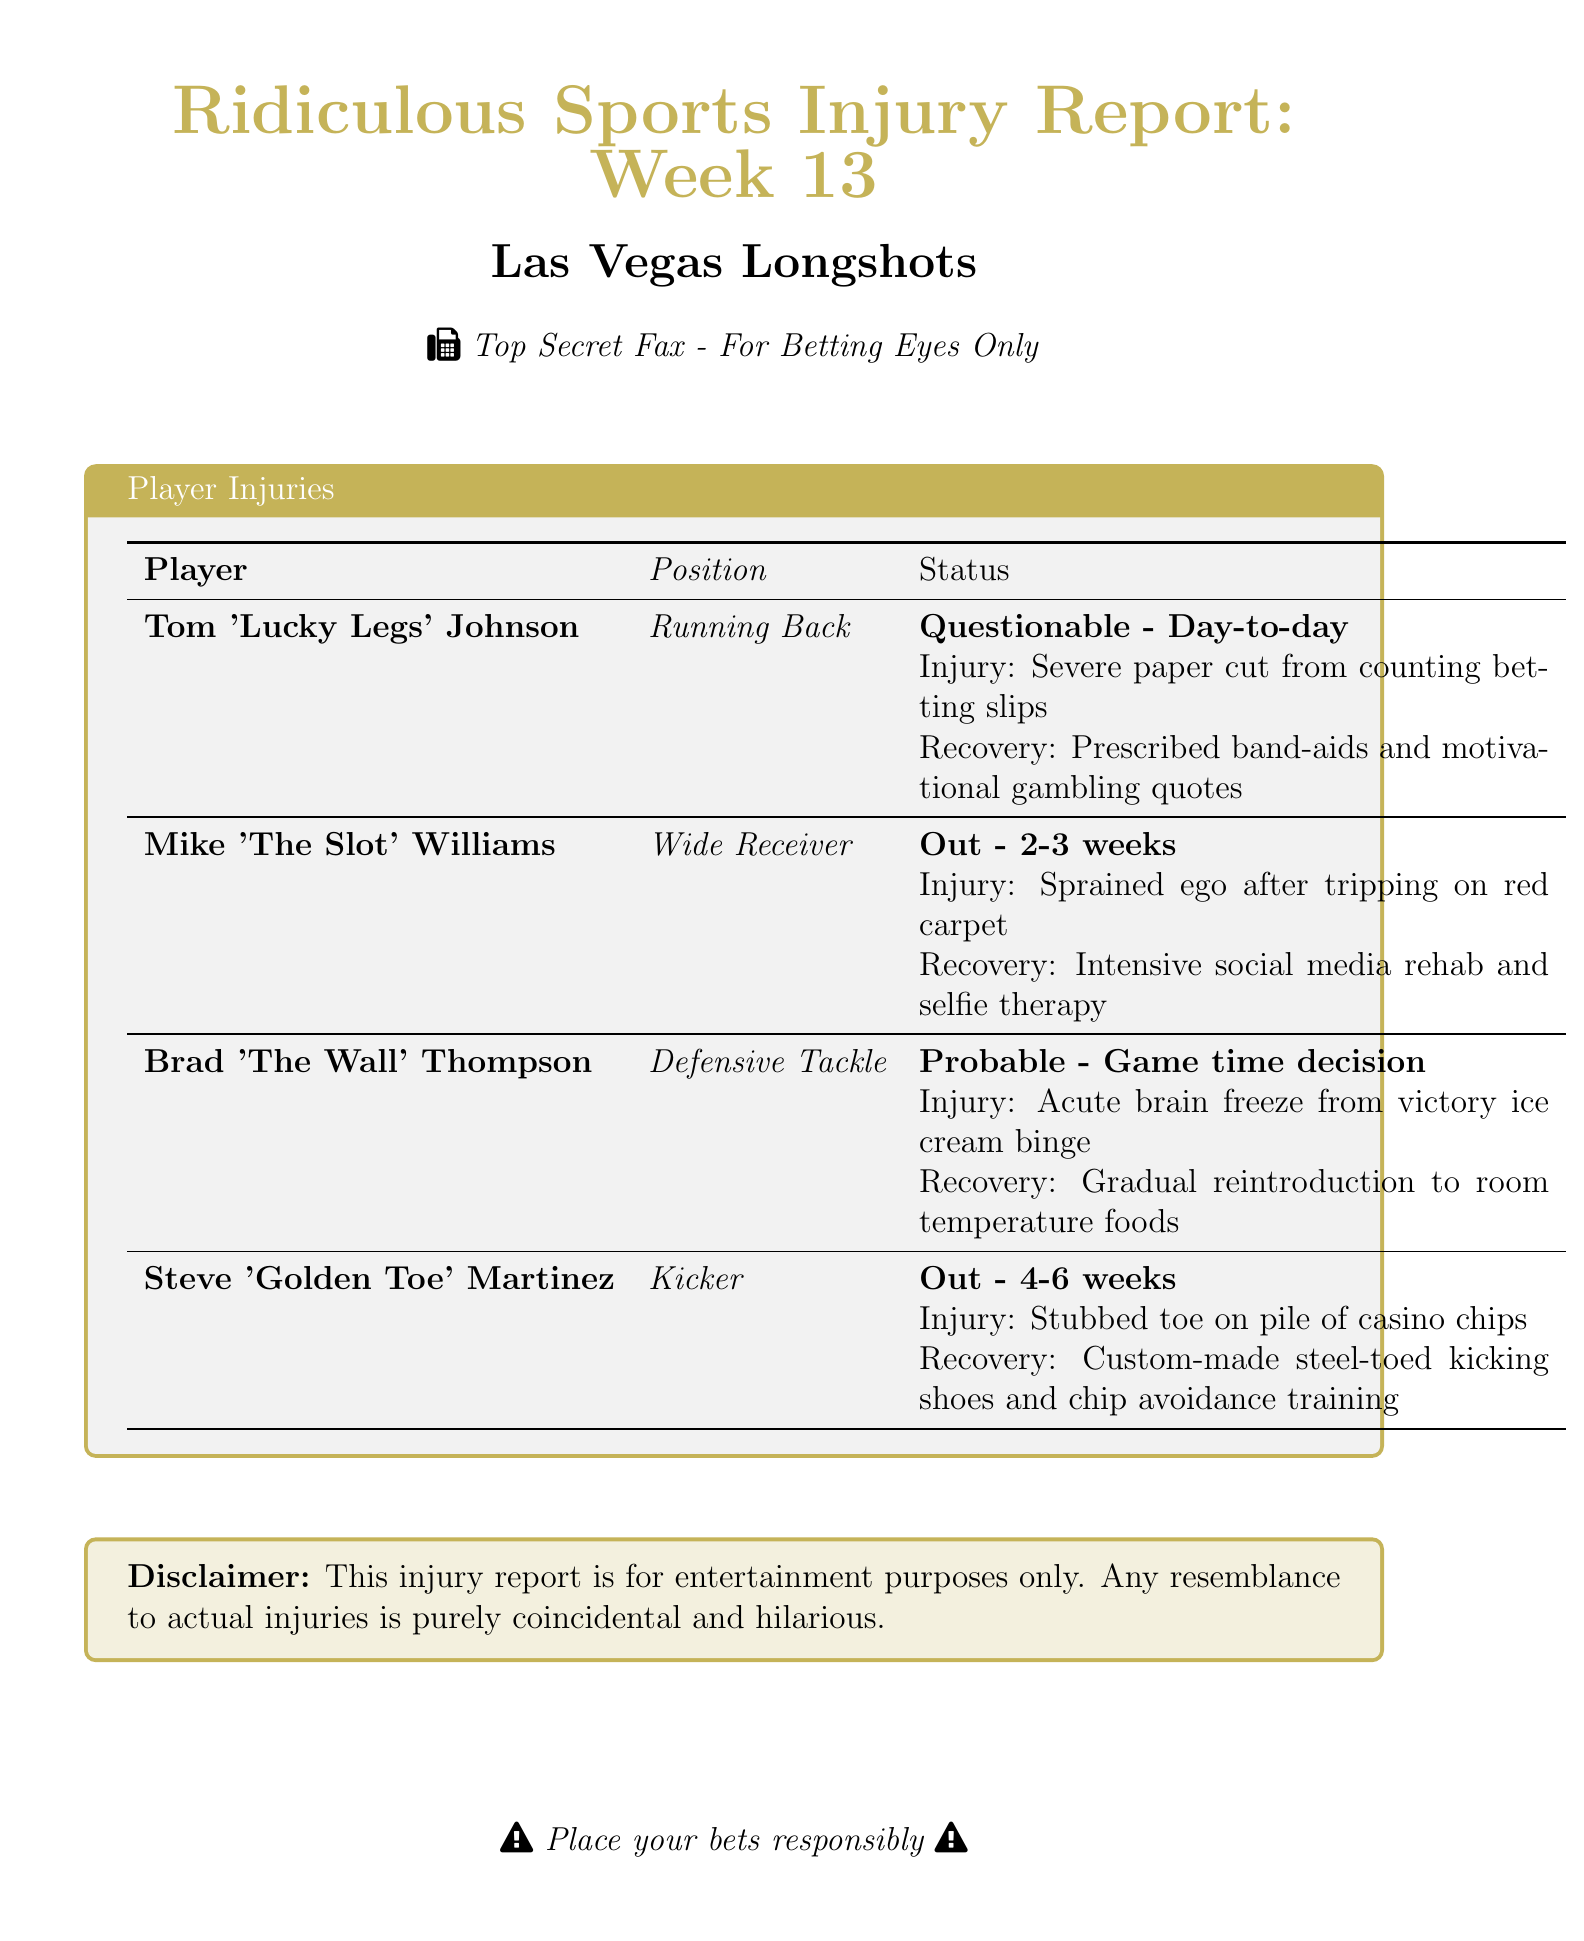What is Tom Johnson's injury? Tom Johnson's injury is a severe paper cut from counting betting slips, as listed in the report.
Answer: Severe paper cut How long is Mike Williams out for? The report states that Mike Williams is out for 2-3 weeks.
Answer: 2-3 weeks What is Brad Thompson's recovery condition? Brad Thompson's recovery involves a gradual reintroduction to room temperature foods according to the report.
Answer: Gradual reintroduction to room temperature foods Which player is referred to as 'Golden Toe'? The report identifies Steve Martinez as 'Golden Toe' in the injury details.
Answer: Steve Martinez What is the expected recovery time for Steve Martinez? The report indicates that Steve Martinez's recovery time is 4-6 weeks.
Answer: 4-6 weeks What kind of therapy is Mike Williams undergoing? Mike Williams is undergoing intensive social media rehab and selfie therapy as recovery measures.
Answer: Intensive social media rehab and selfie therapy What is the status of Tom Johnson? The report states that Tom Johnson's status is questionable and day-to-day.
Answer: Questionable - Day-to-day Is this injury report intended for serious purposes? The disclaimer in the document specifies that this injury report is for entertainment purposes only.
Answer: For entertainment purposes only 